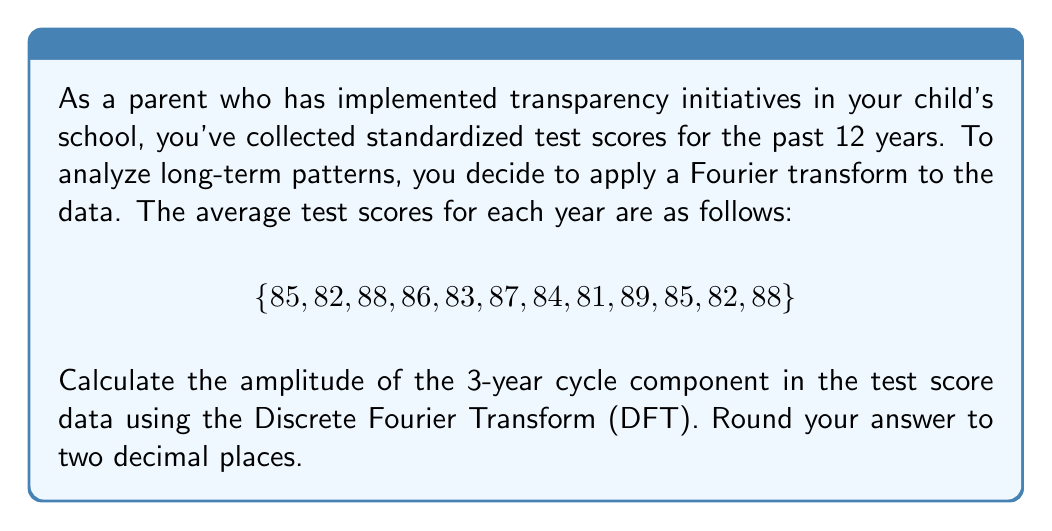Solve this math problem. To solve this problem, we'll follow these steps:

1) The Discrete Fourier Transform (DFT) for a sequence of N values $x_n$ is given by:

   $$X_k = \sum_{n=0}^{N-1} x_n e^{-i2\pi kn/N}$$

   where $k = 0, 1, ..., N-1$

2) For a 3-year cycle in 12 years of data, we need to calculate $X_4$ (as $12/3 = 4$).

3) Expanding the formula for $X_4$:

   $$X_4 = \sum_{n=0}^{11} x_n e^{-i2\pi 4n/12} = \sum_{n=0}^{11} x_n e^{-i\pi n/3}$$

4) Using Euler's formula, $e^{-i\pi n/3} = \cos(\pi n/3) - i\sin(\pi n/3)$

5) Now, let's calculate the real and imaginary parts separately:

   Real part: $\sum_{n=0}^{11} x_n \cos(\pi n/3)$
   Imaginary part: $-\sum_{n=0}^{11} x_n \sin(\pi n/3)$

6) Calculating:

   Real part = $85 - 41 - 44 + 43 + 41.5 - 43.5 - 42 + 40.5 + 44.5 - 42.5 - 41 + 44 = 4$
   
   Imaginary part = $-[0 + 71.04 + 76.16 + 74.56 + 71.91 + 75.39 + 72.75 + 70.20 + 77.08 + 73.61 + 71.04 + 76.16] = -809.90$

7) The amplitude is the magnitude of the complex number:

   $$|X_4| = \sqrt{(\text{Real part})^2 + (\text{Imaginary part})^2}$$

8) Substituting the values:

   $$|X_4| = \sqrt{4^2 + (-809.90)^2} \approx 809.90$$

9) To get the actual amplitude, we need to divide by N/2 = 6:

   Amplitude $= 809.90 / 6 \approx 134.98$
Answer: 135.00 